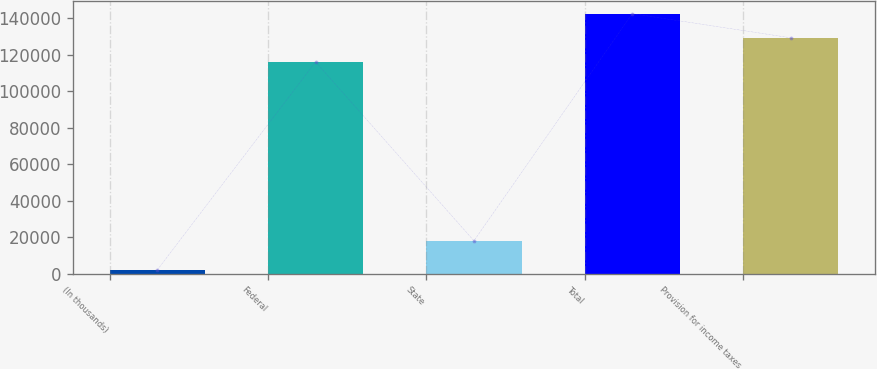Convert chart. <chart><loc_0><loc_0><loc_500><loc_500><bar_chart><fcel>(In thousands)<fcel>Federal<fcel>State<fcel>Total<fcel>Provision for income taxes<nl><fcel>2007<fcel>116125<fcel>18031<fcel>142555<fcel>129340<nl></chart> 